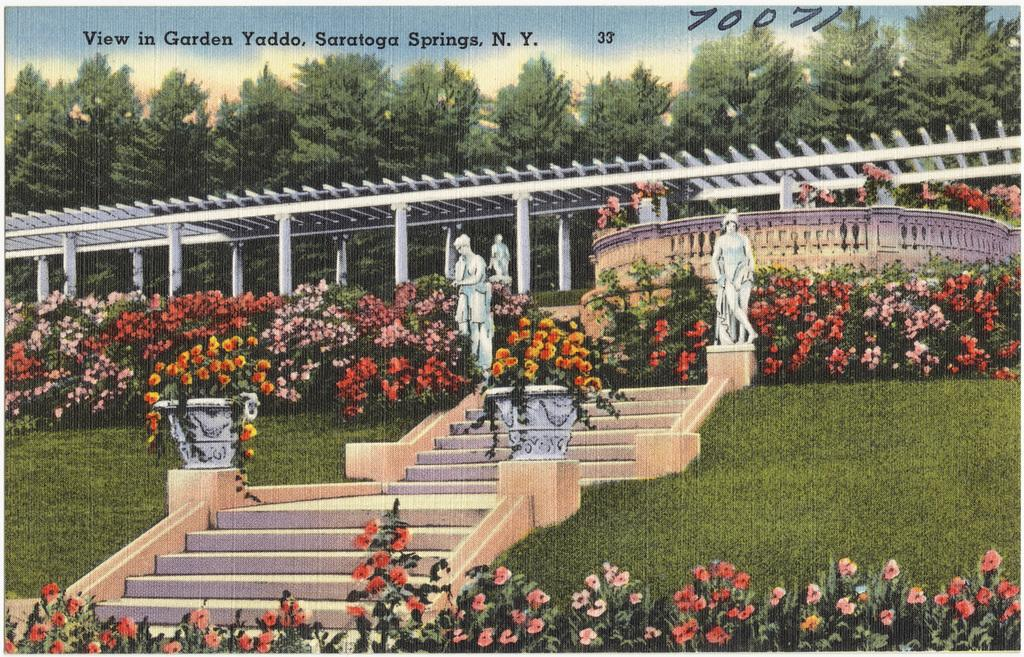<image>
Share a concise interpretation of the image provided. A painting of stairs that says it is of Graden Yaddo of Saratoga Springs. 